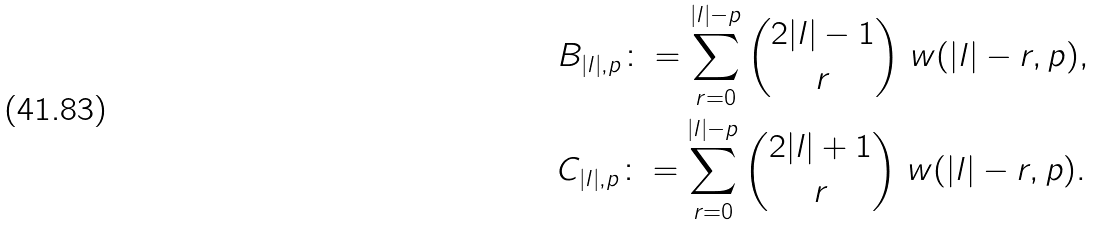Convert formula to latex. <formula><loc_0><loc_0><loc_500><loc_500>& B _ { | l | , p } \colon = \sum _ { r = 0 } ^ { | l | - p } { 2 | l | - 1 \choose r } \ w ( | l | - r , p ) , \\ & C _ { | l | , p } \colon = \sum _ { r = 0 } ^ { | l | - p } { 2 | l | + 1 \choose r } \ w ( | l | - r , p ) .</formula> 